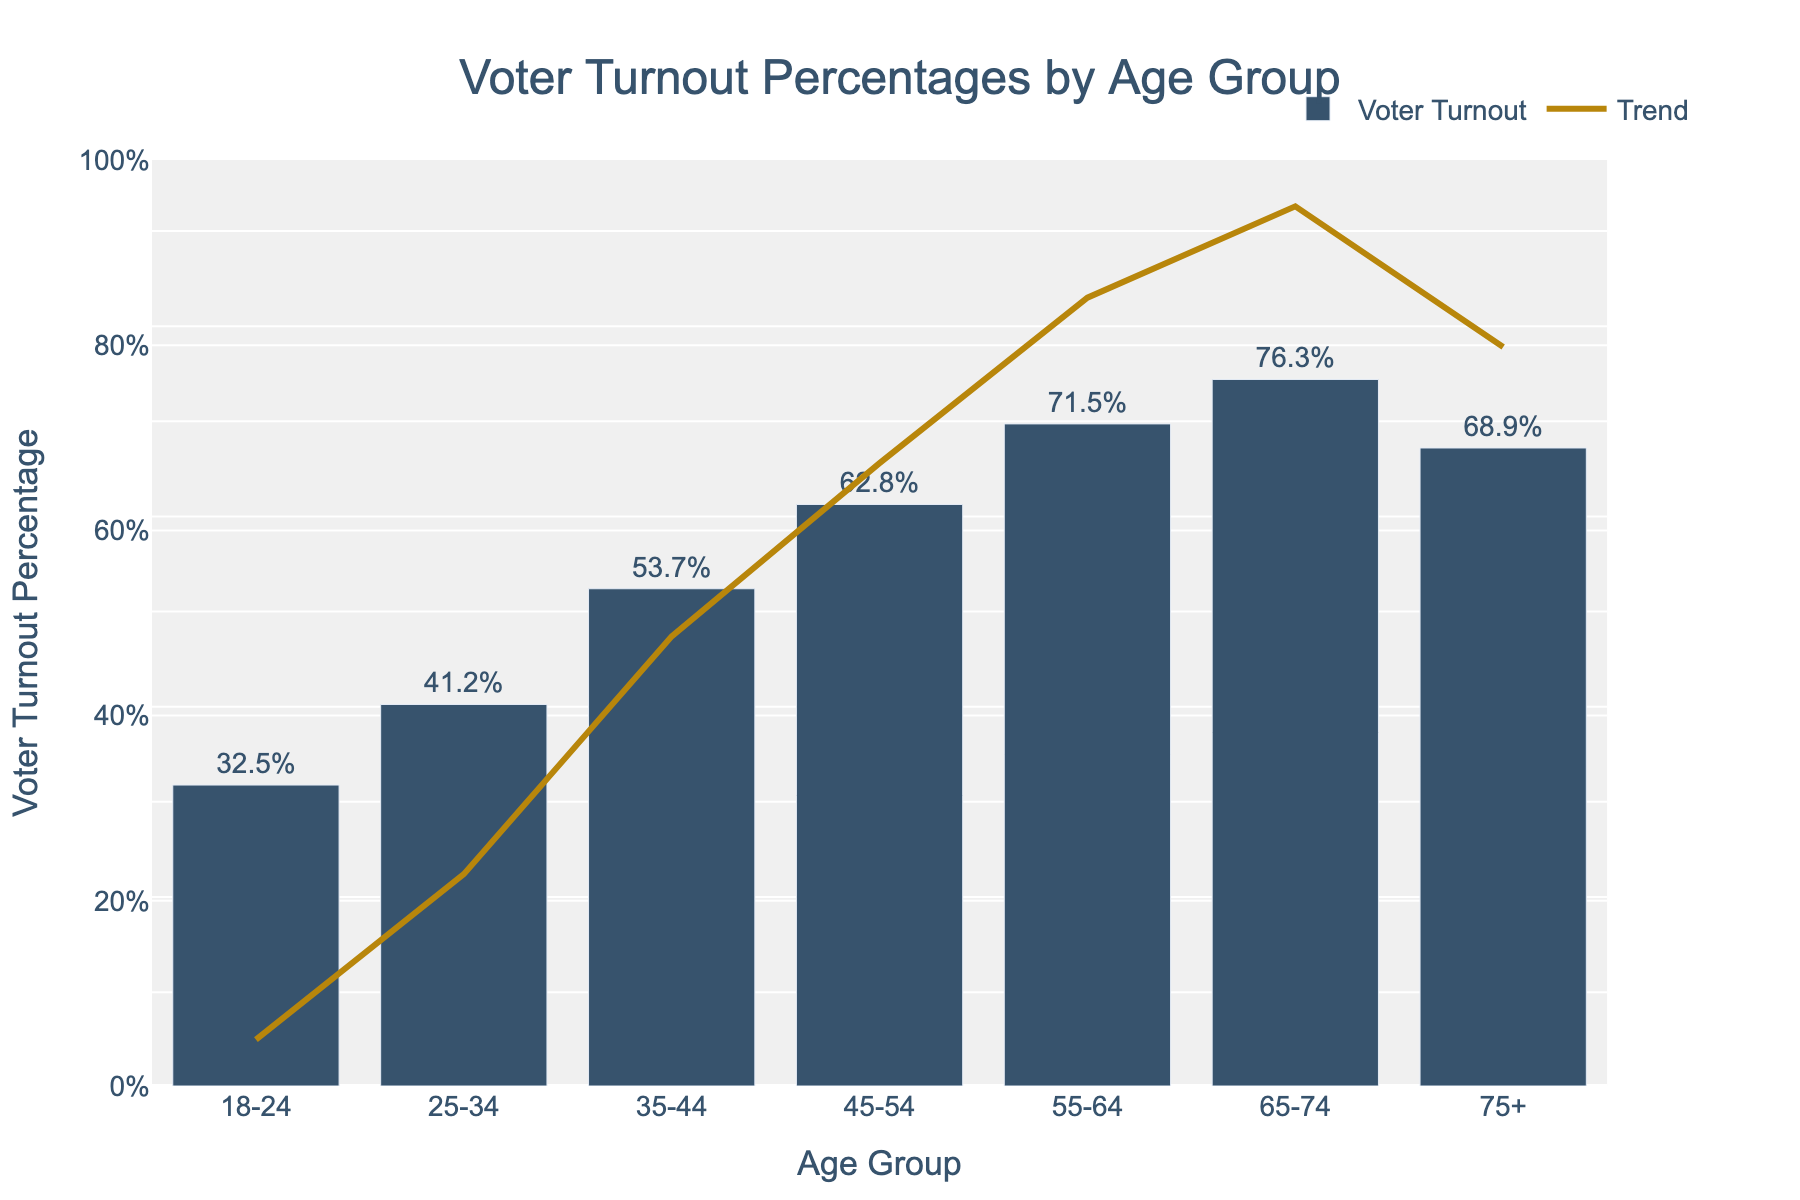What's the voter turnout percentage for the 55-64 age group? Refer to the bar corresponding to the "55-64" age group and read the percentage value. It is labeled on top of the bar as 71.5%.
Answer: 71.5% Which age group has the lowest voter turnout? Compare all the bars and find the shortest one, which corresponds to the "18-24" age group. The label on top shows 32.5%.
Answer: 18-24 What is the difference in voter turnout percentage between the 18-24 and 65-74 age groups? Subtract the voter turnout percentage of the "18-24" age group (32.5%) from the "65-74" age group (76.3%) to find the difference. 76.3% - 32.5% = 43.8%
Answer: 43.8% Which age group has a higher voter turnout: 25-34 or 75+? Compare the heights of the bars corresponding to "25-34" (41.2%) and "75+" (68.9%). The "75+" age group has a higher turnout percentage.
Answer: 75+ What is the average voter turnout percentage across all age groups? Sum all the voter turnout percentages (32.5 + 41.2 + 53.7 + 62.8 + 71.5 + 76.3 + 68.9) = 406.9 and then divide by the number of age groups (7). 406.9 / 7 = 58.13%
Answer: 58.13% Is the voter turnout for the 45-54 age group higher or lower than the overall average? First, calculate the average voter turnout percentage (which we found to be 58.13%). Then compare it with the voter turnout of the "45-54" age group (62.8%). Since 62.8% is greater than 58.13%, it is higher.
Answer: Higher Which age group shows the most significant drop in voter turnout percentage when compared to the previous age group? Calculate the differences between each consecutive age group's voter turnout percentages: (41.2%-32.5% = 8.7%), (53.7%-41.2% = 12.5%), (62.8%-53.7% = 9.1%), (71.5%-62.8% = 8.7%), (76.3%-71.5% = 4.8%), (68.9%-76.3% = -7.4%). The most significant drop is between 65-74 and 75+, with a difference of -7.4%.
Answer: 75+ What is the median voter turnout percentage? Arrange the percentages in ascending order: 32.5, 41.2, 53.7, 62.8, 68.9, 71.5, 76.3. The median is the middle value, which is 62.8%.
Answer: 62.8% How does the voter turnout trend line behave across the age groups? Observe the orange trend line plotted along with the bar chart. It generally increases from "18-24" to "65-74" and then slightly drops for the "75+" age group.
Answer: Mostly increasing, with a slight drop at the end 